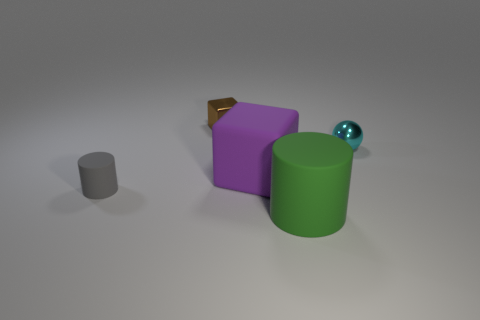The brown metal thing that is the same size as the cyan shiny thing is what shape?
Offer a very short reply. Cube. There is a cyan shiny object in front of the metal thing that is behind the shiny object right of the big cylinder; what shape is it?
Give a very brief answer. Sphere. Do the green rubber object and the thing that is left of the tiny metallic block have the same shape?
Your answer should be compact. Yes. How many big objects are either blue things or blocks?
Make the answer very short. 1. Are there any rubber cylinders that have the same size as the purple rubber thing?
Ensure brevity in your answer.  Yes. There is a rubber thing that is behind the cylinder that is to the left of the small shiny object that is to the left of the tiny cyan object; what color is it?
Give a very brief answer. Purple. Is the small cylinder made of the same material as the block that is to the right of the brown cube?
Your response must be concise. Yes. What size is the gray matte thing that is the same shape as the large green object?
Offer a very short reply. Small. Are there an equal number of big rubber cubes that are in front of the brown shiny object and small cyan metal balls that are in front of the large green thing?
Give a very brief answer. No. What number of other objects are the same material as the sphere?
Keep it short and to the point. 1. 